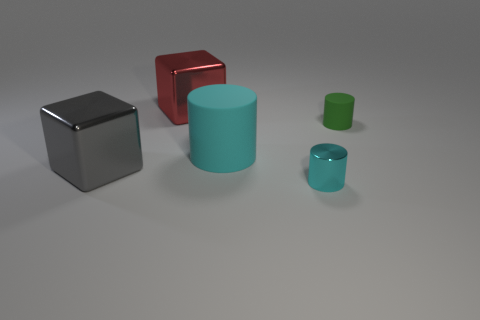Add 5 tiny yellow matte cubes. How many objects exist? 10 Subtract all cylinders. How many objects are left? 2 Subtract 0 cyan balls. How many objects are left? 5 Subtract all tiny brown cylinders. Subtract all big cylinders. How many objects are left? 4 Add 2 cubes. How many cubes are left? 4 Add 3 small blue metal cylinders. How many small blue metal cylinders exist? 3 